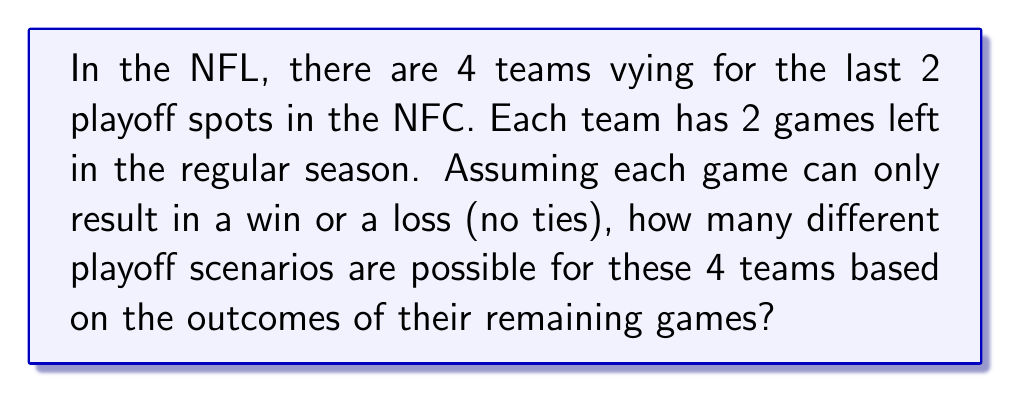Give your solution to this math problem. Let's approach this step-by-step:

1) First, we need to consider how many possible outcomes each team has for their remaining games:
   - Each team has 2 games left
   - Each game can be either a win (W) or a loss (L)
   - So, each team has 4 possible outcomes: WW, WL, LW, LL

2) Now, we need to consider how many ways these outcomes can combine for all 4 teams:
   - Each team's outcome is independent of the others
   - We can use the multiplication principle of counting

3) Let's set up our calculation:
   - Team 1 has 4 possible outcomes
   - Team 2 has 4 possible outcomes
   - Team 3 has 4 possible outcomes
   - Team 4 has 4 possible outcomes

4) The total number of scenarios is:

   $$ 4 \times 4 \times 4 \times 4 = 4^4 = 256 $$

Therefore, there are 256 different possible scenarios for how these 4 teams could finish their last 2 games.
Answer: 256 different playoff scenarios 